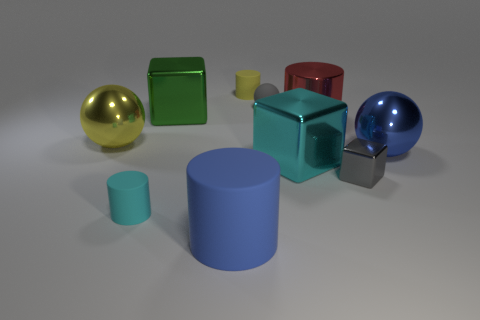Can you describe the colors of the objects present? Certainly, there are objects in gold, green, red, yellow, blue, and two shades of gray. 